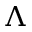<formula> <loc_0><loc_0><loc_500><loc_500>\Lambda</formula> 